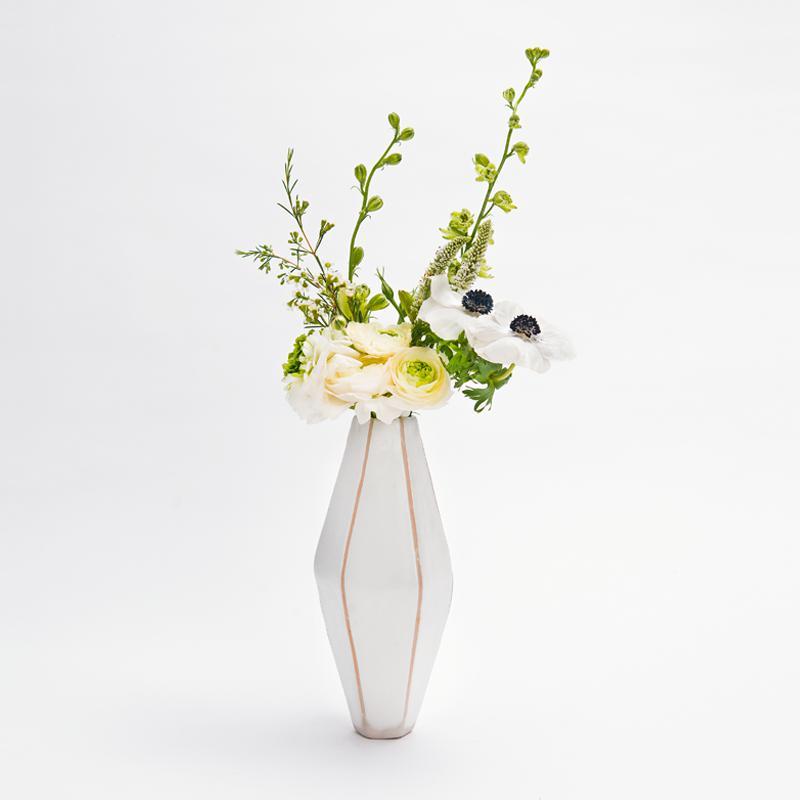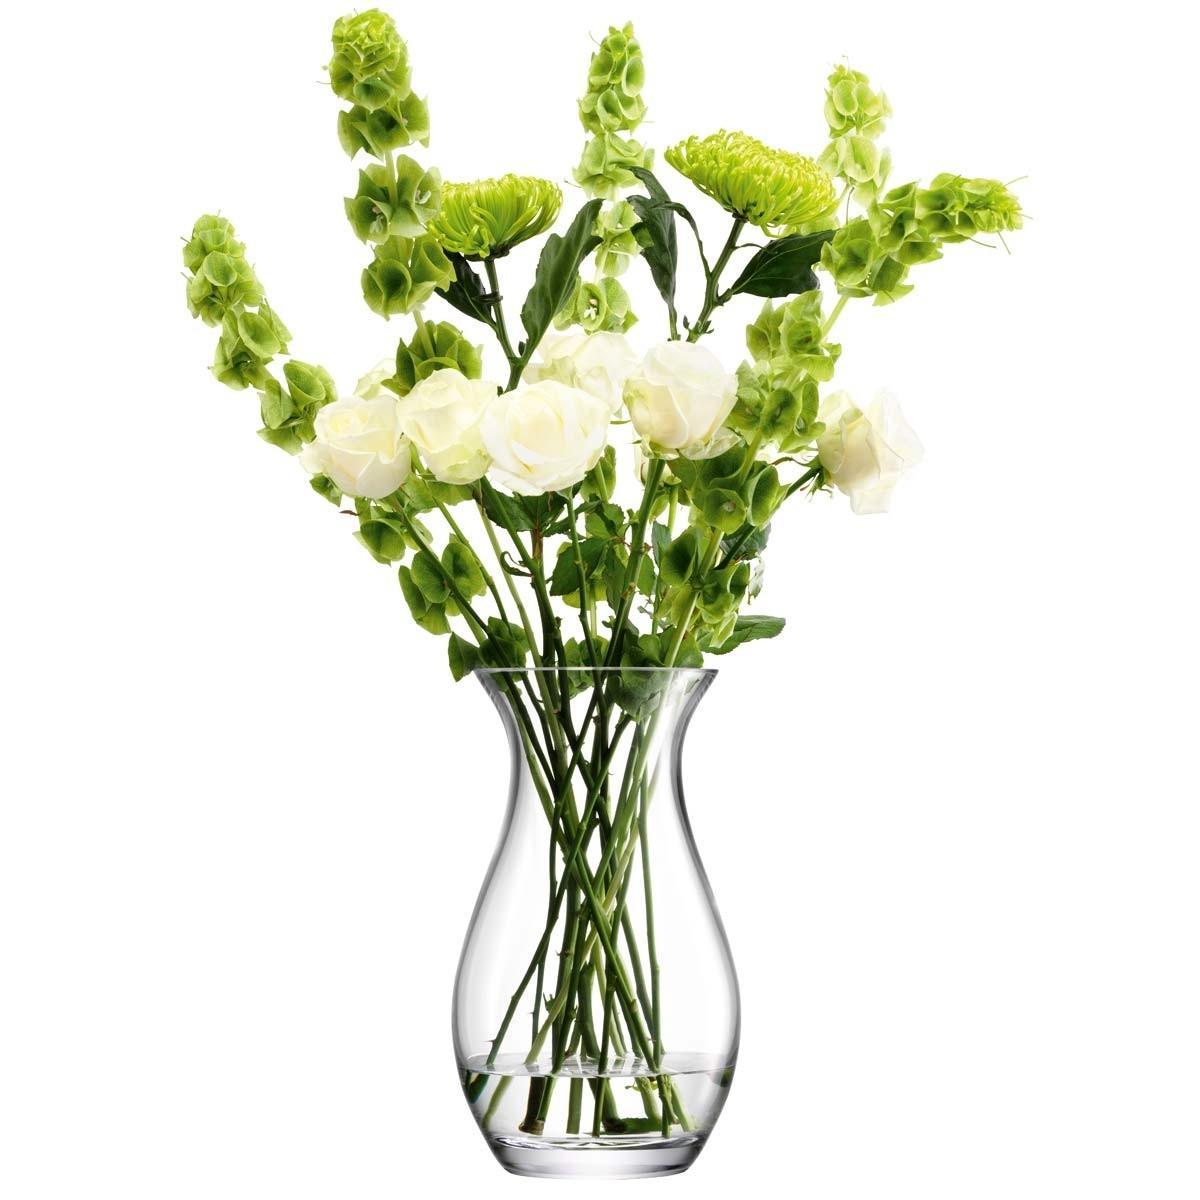The first image is the image on the left, the second image is the image on the right. For the images displayed, is the sentence "The flowers in the clear glass vase are white with green stems." factually correct? Answer yes or no. Yes. The first image is the image on the left, the second image is the image on the right. Examine the images to the left and right. Is the description "There are two vases with stems that are visible" accurate? Answer yes or no. No. 